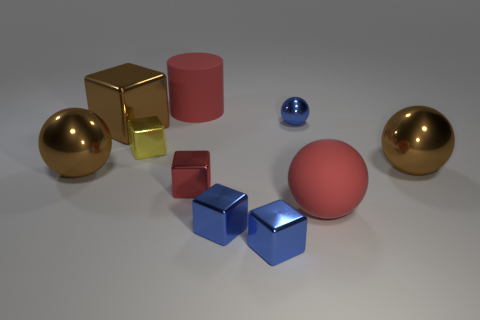There is a ball that is both on the right side of the matte cylinder and to the left of the red rubber ball; what color is it?
Offer a very short reply. Blue. There is a rubber object behind the rubber sphere; how many red things are in front of it?
Offer a terse response. 2. Are there any cyan matte objects that have the same shape as the small yellow metallic object?
Your answer should be compact. No. There is a red matte thing that is in front of the small red metal thing; is it the same shape as the tiny blue thing that is behind the yellow metal block?
Provide a short and direct response. Yes. What number of objects are either small blue metallic objects or rubber spheres?
Make the answer very short. 4. There is a yellow metallic object that is the same shape as the red metal object; what is its size?
Keep it short and to the point. Small. Are there more metal things that are left of the tiny red metallic thing than tiny red blocks?
Make the answer very short. Yes. Do the tiny red object and the large cylinder have the same material?
Provide a short and direct response. No. How many objects are either big brown objects that are in front of the large brown shiny block or big rubber things to the right of the large red rubber cylinder?
Make the answer very short. 3. What color is the large metallic thing that is the same shape as the small yellow object?
Provide a succinct answer. Brown. 